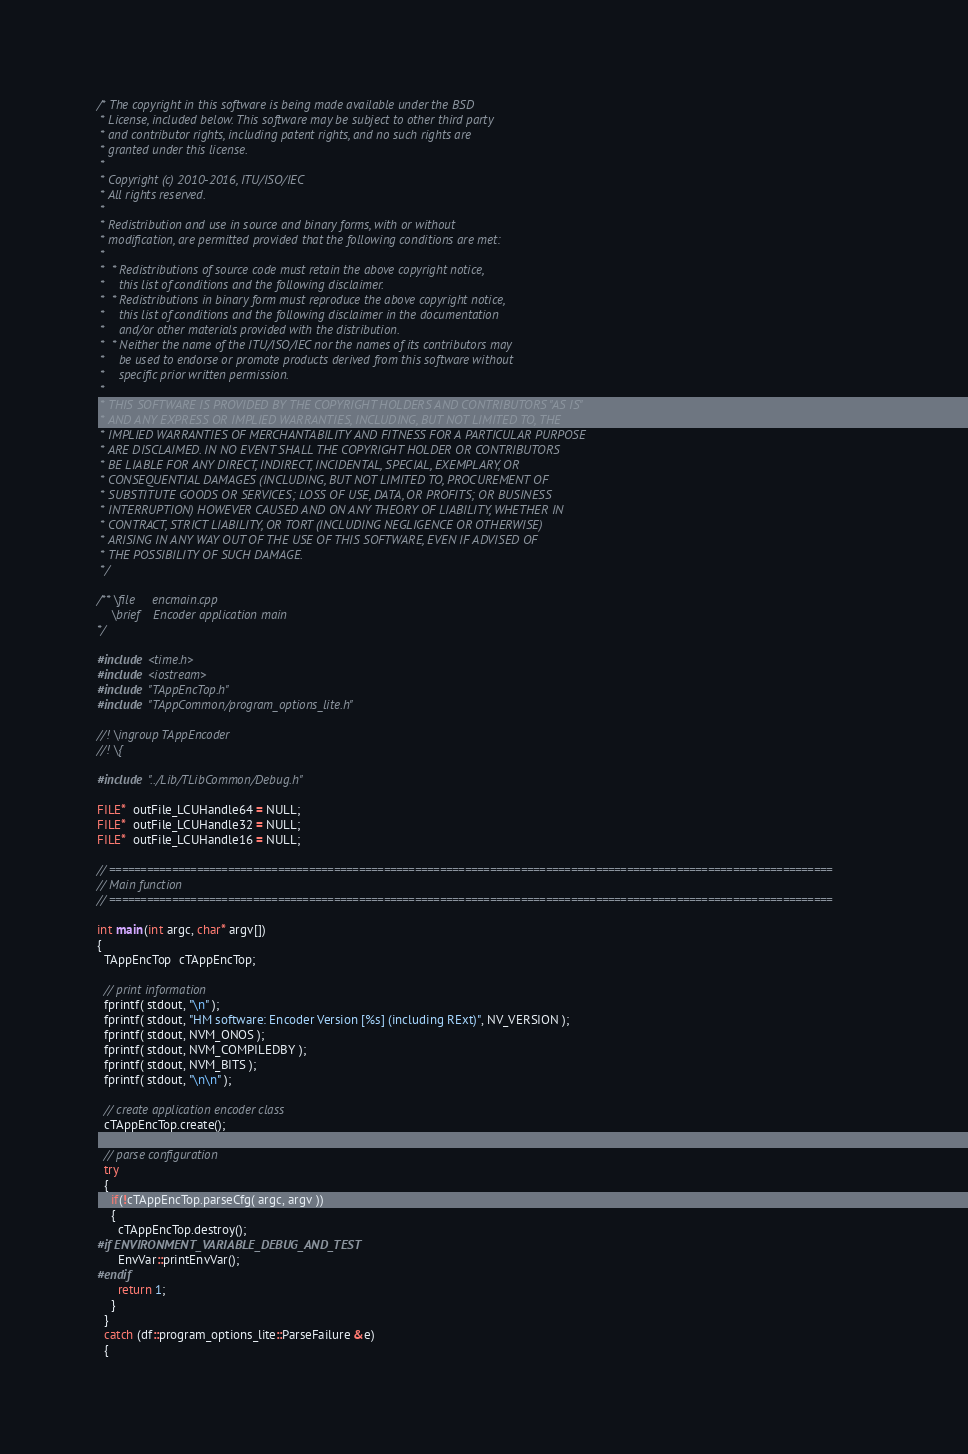<code> <loc_0><loc_0><loc_500><loc_500><_C++_>/* The copyright in this software is being made available under the BSD
 * License, included below. This software may be subject to other third party
 * and contributor rights, including patent rights, and no such rights are
 * granted under this license.
 *
 * Copyright (c) 2010-2016, ITU/ISO/IEC
 * All rights reserved.
 *
 * Redistribution and use in source and binary forms, with or without
 * modification, are permitted provided that the following conditions are met:
 *
 *  * Redistributions of source code must retain the above copyright notice,
 *    this list of conditions and the following disclaimer.
 *  * Redistributions in binary form must reproduce the above copyright notice,
 *    this list of conditions and the following disclaimer in the documentation
 *    and/or other materials provided with the distribution.
 *  * Neither the name of the ITU/ISO/IEC nor the names of its contributors may
 *    be used to endorse or promote products derived from this software without
 *    specific prior written permission.
 *
 * THIS SOFTWARE IS PROVIDED BY THE COPYRIGHT HOLDERS AND CONTRIBUTORS "AS IS"
 * AND ANY EXPRESS OR IMPLIED WARRANTIES, INCLUDING, BUT NOT LIMITED TO, THE
 * IMPLIED WARRANTIES OF MERCHANTABILITY AND FITNESS FOR A PARTICULAR PURPOSE
 * ARE DISCLAIMED. IN NO EVENT SHALL THE COPYRIGHT HOLDER OR CONTRIBUTORS
 * BE LIABLE FOR ANY DIRECT, INDIRECT, INCIDENTAL, SPECIAL, EXEMPLARY, OR
 * CONSEQUENTIAL DAMAGES (INCLUDING, BUT NOT LIMITED TO, PROCUREMENT OF
 * SUBSTITUTE GOODS OR SERVICES; LOSS OF USE, DATA, OR PROFITS; OR BUSINESS
 * INTERRUPTION) HOWEVER CAUSED AND ON ANY THEORY OF LIABILITY, WHETHER IN
 * CONTRACT, STRICT LIABILITY, OR TORT (INCLUDING NEGLIGENCE OR OTHERWISE)
 * ARISING IN ANY WAY OUT OF THE USE OF THIS SOFTWARE, EVEN IF ADVISED OF
 * THE POSSIBILITY OF SUCH DAMAGE.
 */

/** \file     encmain.cpp
    \brief    Encoder application main
*/

#include <time.h>
#include <iostream>
#include "TAppEncTop.h"
#include "TAppCommon/program_options_lite.h"

//! \ingroup TAppEncoder
//! \{

#include "../Lib/TLibCommon/Debug.h"

FILE*  outFile_LCUHandle64 = NULL;
FILE*  outFile_LCUHandle32 = NULL;
FILE*  outFile_LCUHandle16 = NULL;

// ====================================================================================================================
// Main function
// ====================================================================================================================

int main(int argc, char* argv[])
{
  TAppEncTop  cTAppEncTop;

  // print information
  fprintf( stdout, "\n" );
  fprintf( stdout, "HM software: Encoder Version [%s] (including RExt)", NV_VERSION );
  fprintf( stdout, NVM_ONOS );
  fprintf( stdout, NVM_COMPILEDBY );
  fprintf( stdout, NVM_BITS );
  fprintf( stdout, "\n\n" );

  // create application encoder class
  cTAppEncTop.create();

  // parse configuration
  try
  {
    if(!cTAppEncTop.parseCfg( argc, argv ))
    {
      cTAppEncTop.destroy();
#if ENVIRONMENT_VARIABLE_DEBUG_AND_TEST
      EnvVar::printEnvVar();
#endif
      return 1;
    }
  }
  catch (df::program_options_lite::ParseFailure &e)
  {</code> 